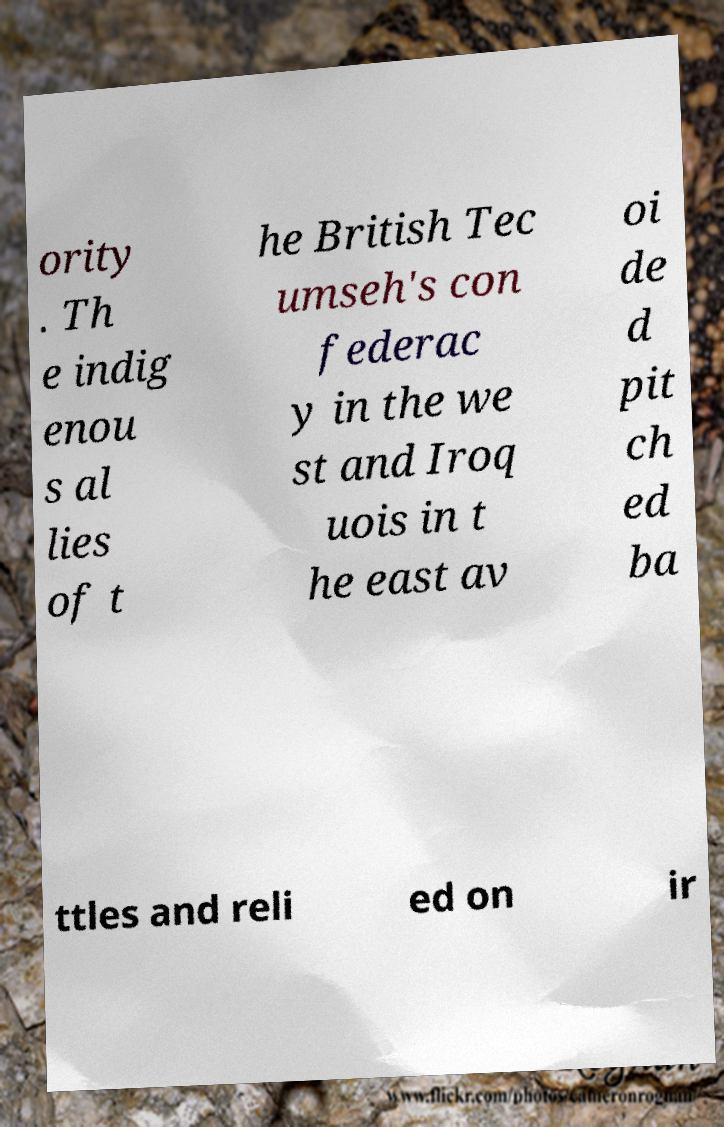Can you accurately transcribe the text from the provided image for me? ority . Th e indig enou s al lies of t he British Tec umseh's con federac y in the we st and Iroq uois in t he east av oi de d pit ch ed ba ttles and reli ed on ir 